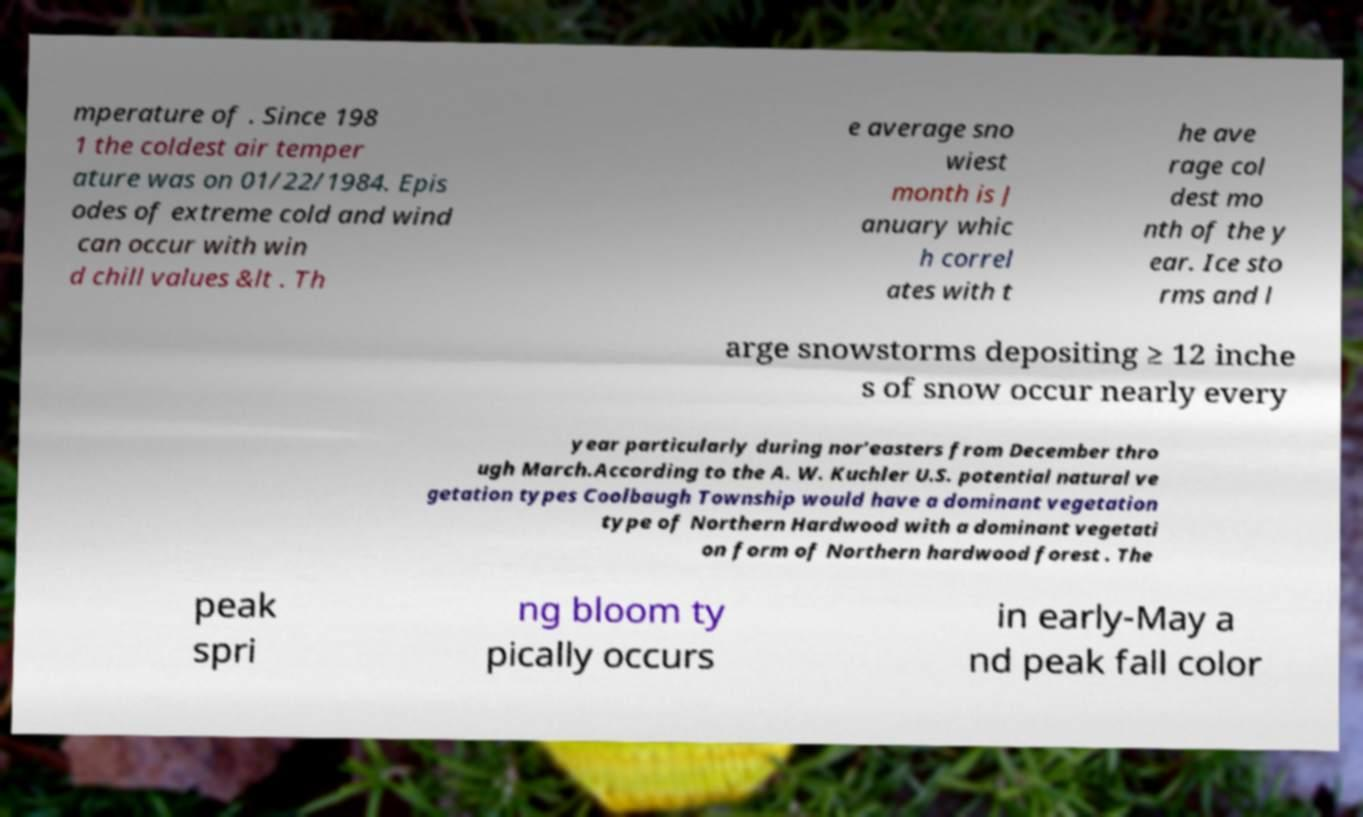Can you read and provide the text displayed in the image?This photo seems to have some interesting text. Can you extract and type it out for me? mperature of . Since 198 1 the coldest air temper ature was on 01/22/1984. Epis odes of extreme cold and wind can occur with win d chill values &lt . Th e average sno wiest month is J anuary whic h correl ates with t he ave rage col dest mo nth of the y ear. Ice sto rms and l arge snowstorms depositing ≥ 12 inche s of snow occur nearly every year particularly during nor’easters from December thro ugh March.According to the A. W. Kuchler U.S. potential natural ve getation types Coolbaugh Township would have a dominant vegetation type of Northern Hardwood with a dominant vegetati on form of Northern hardwood forest . The peak spri ng bloom ty pically occurs in early-May a nd peak fall color 